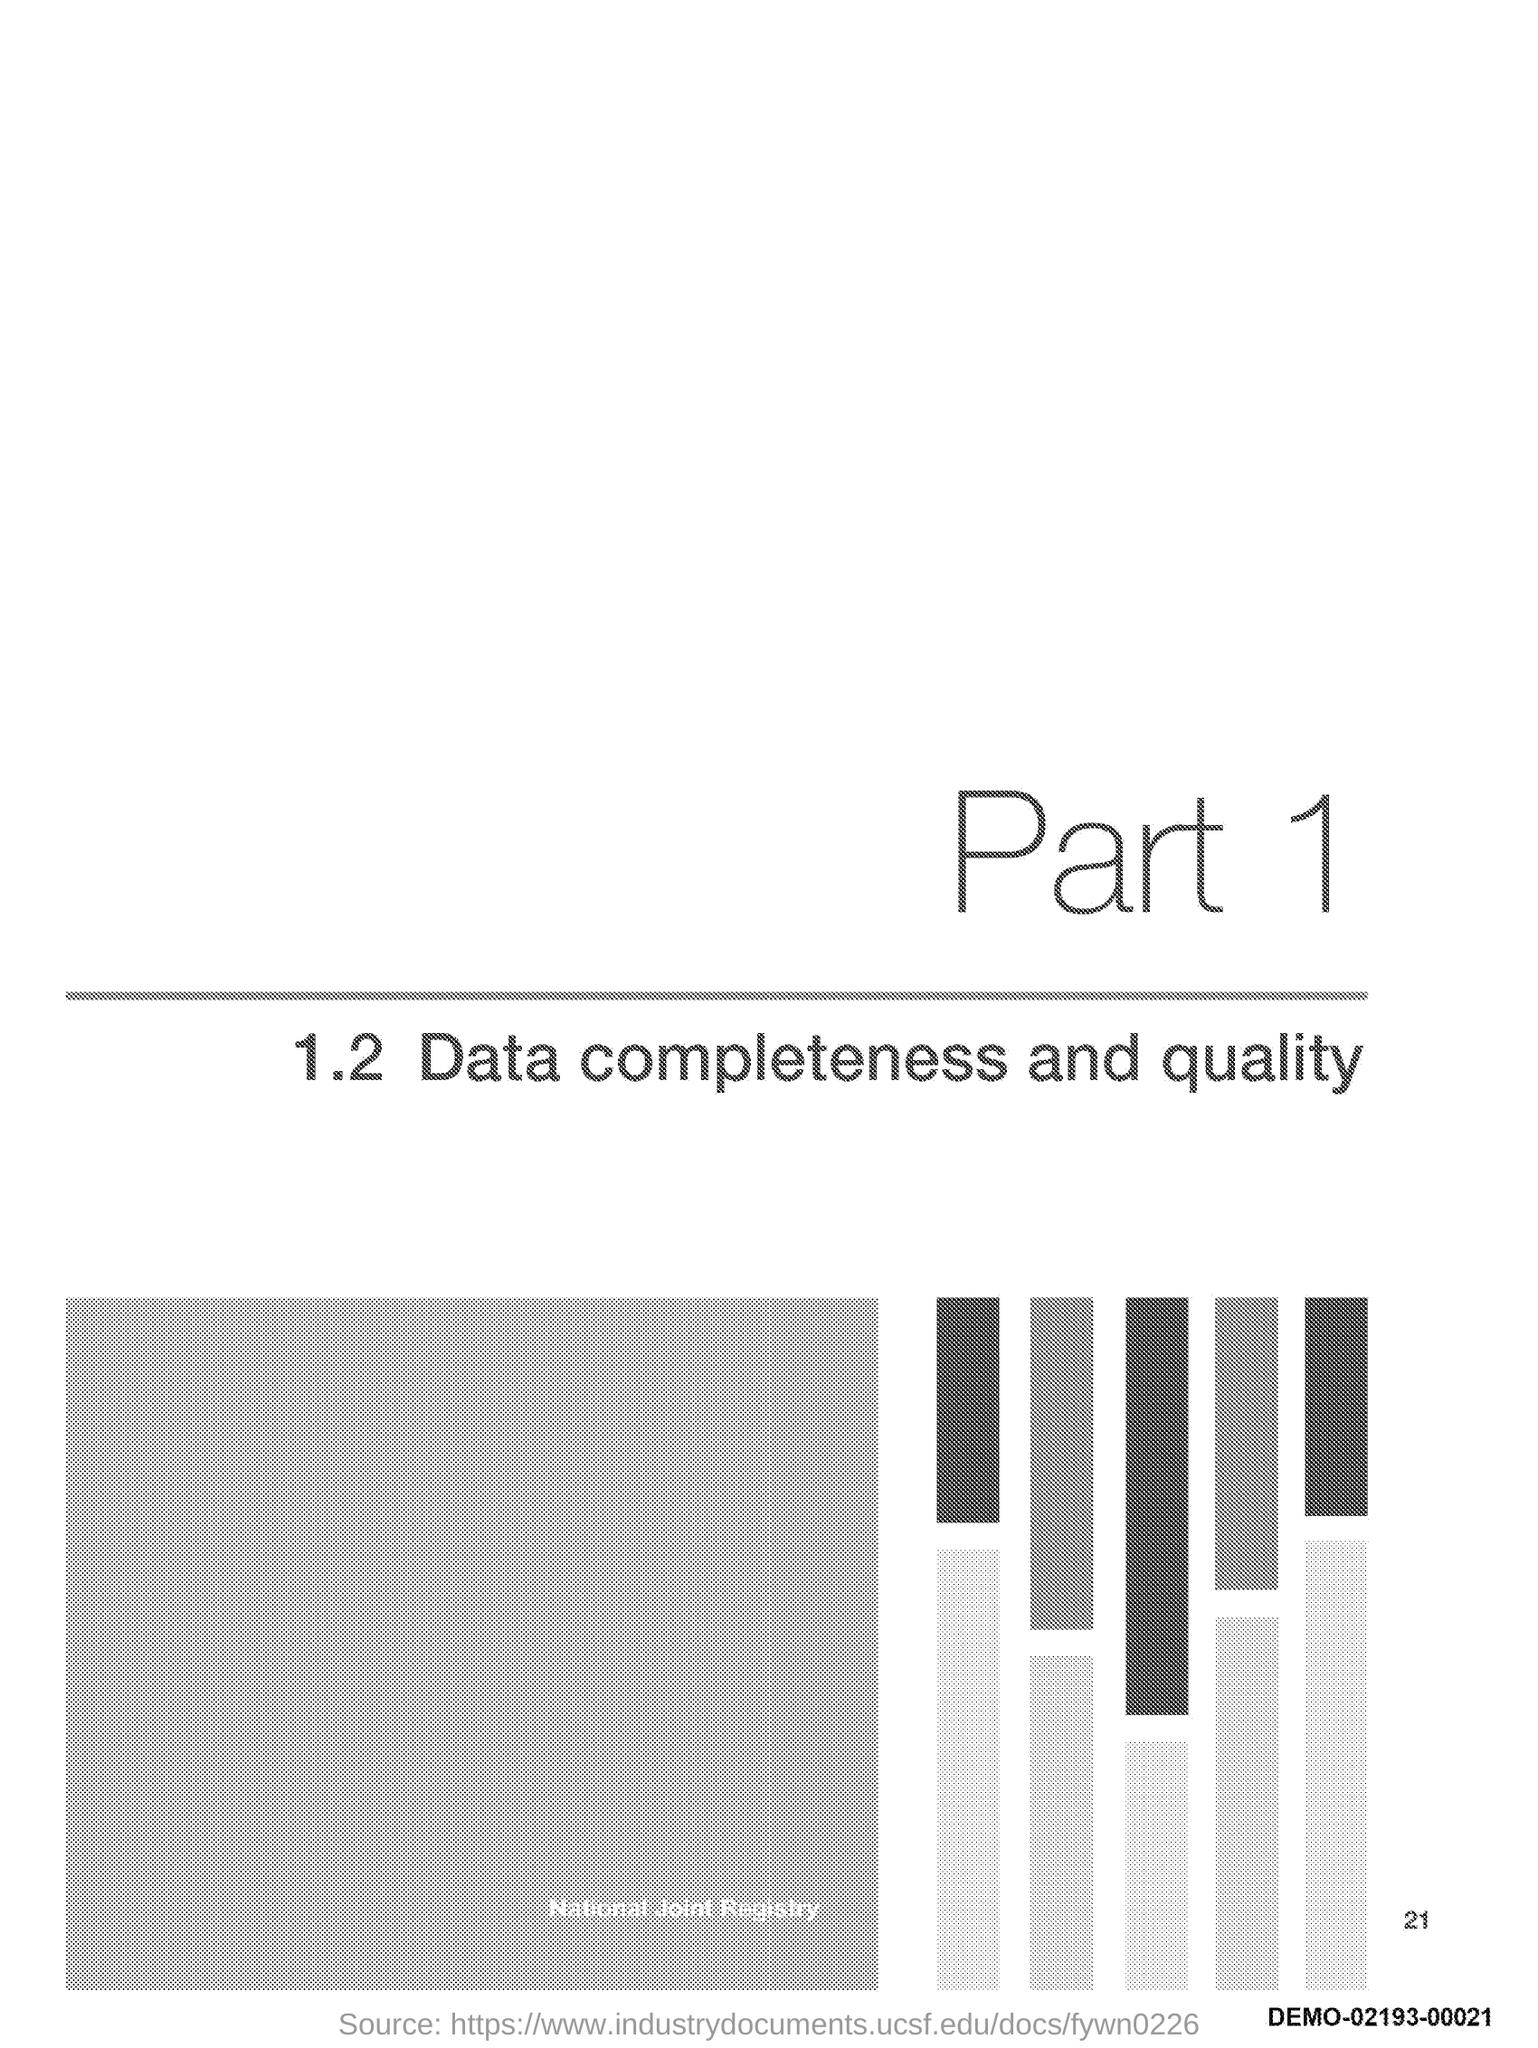Indicate a few pertinent items in this graphic. The document mentions 1.. 